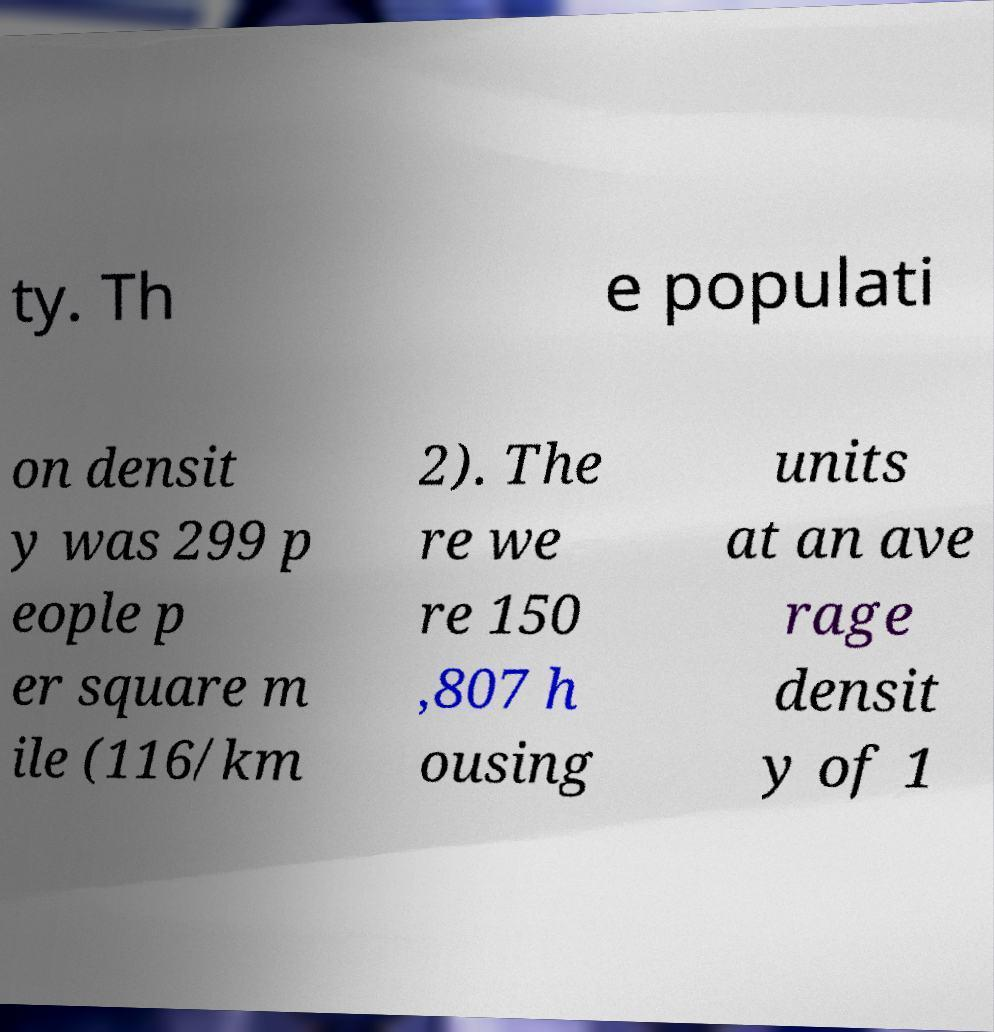Please identify and transcribe the text found in this image. ty. Th e populati on densit y was 299 p eople p er square m ile (116/km 2). The re we re 150 ,807 h ousing units at an ave rage densit y of 1 